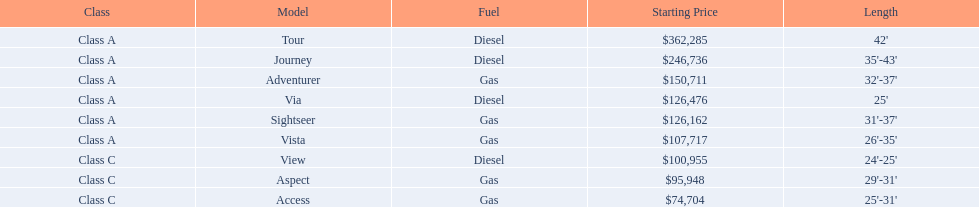Which model has the lowest starting price? Access. Which model has the second most highest starting price? Journey. Which model has the highest price in the winnebago industry? Tour. 